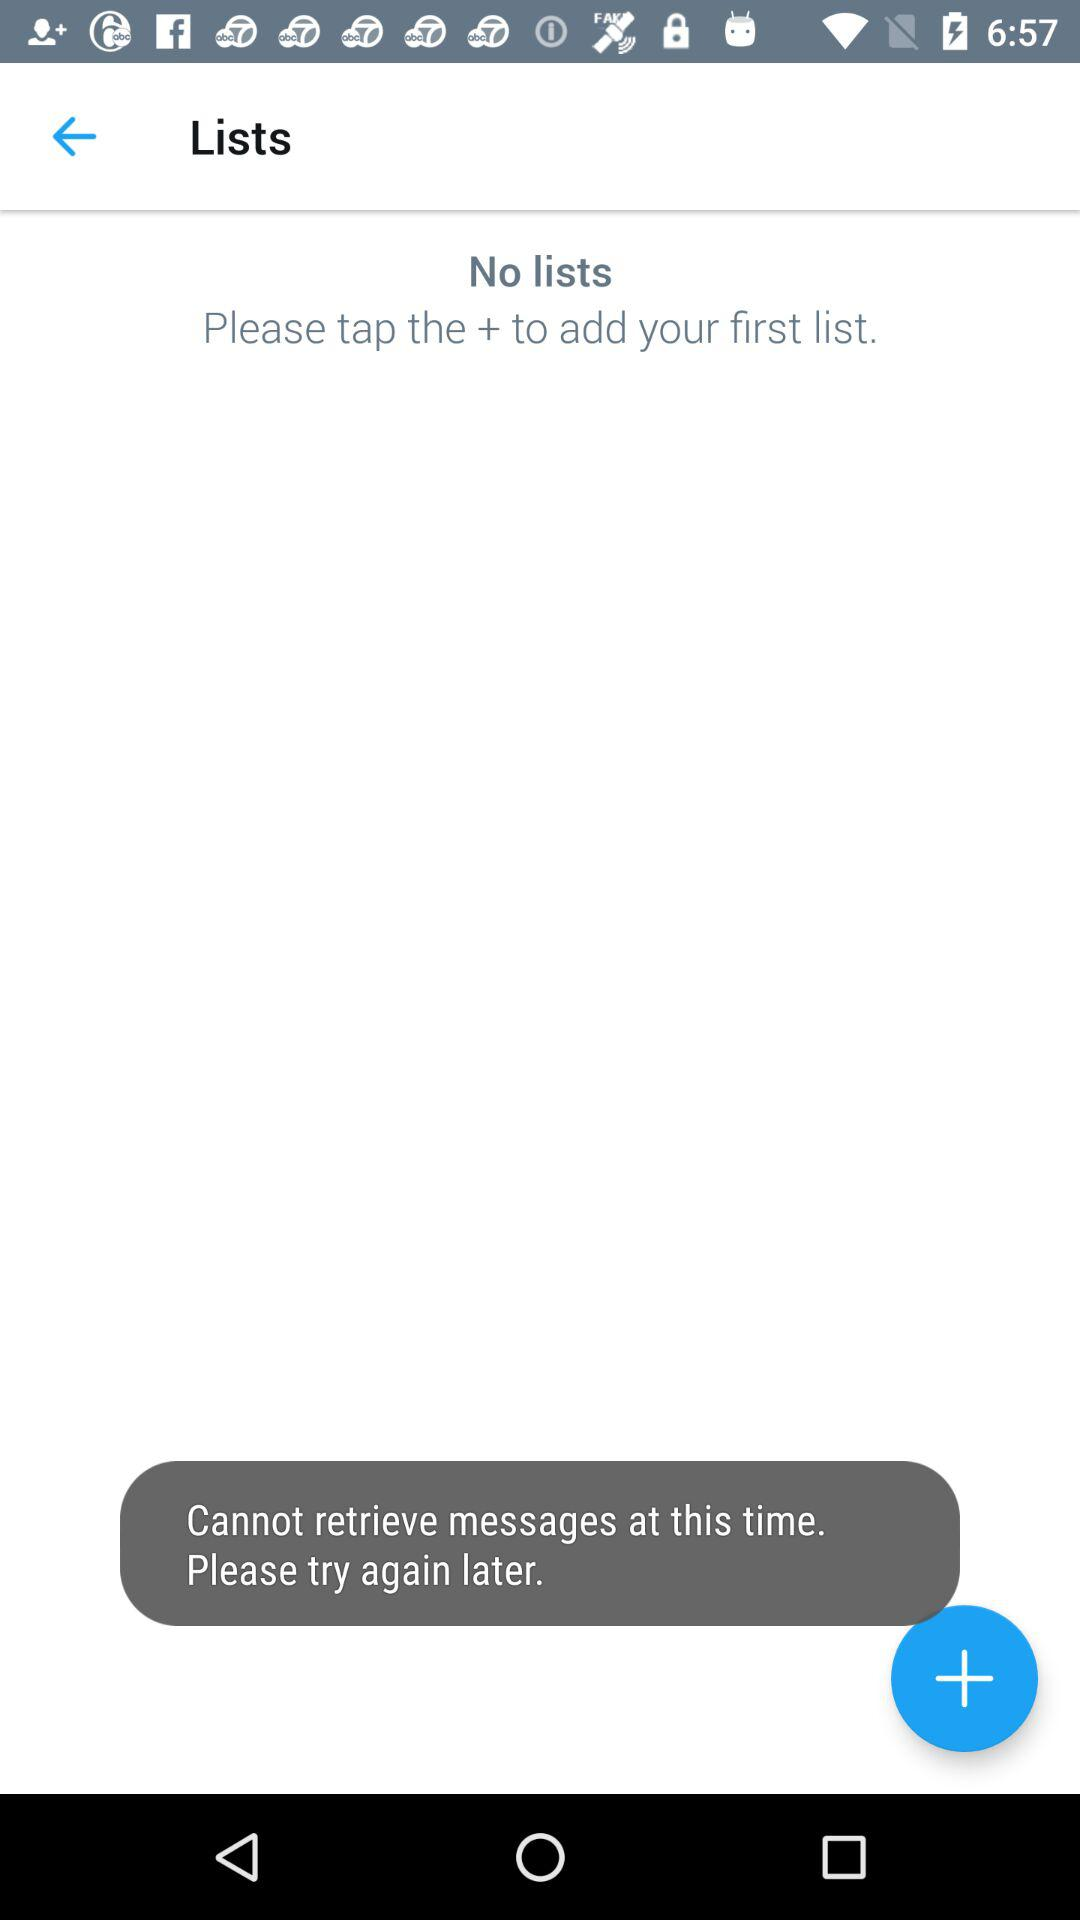What is the application name?
When the provided information is insufficient, respond with <no answer>. <no answer> 